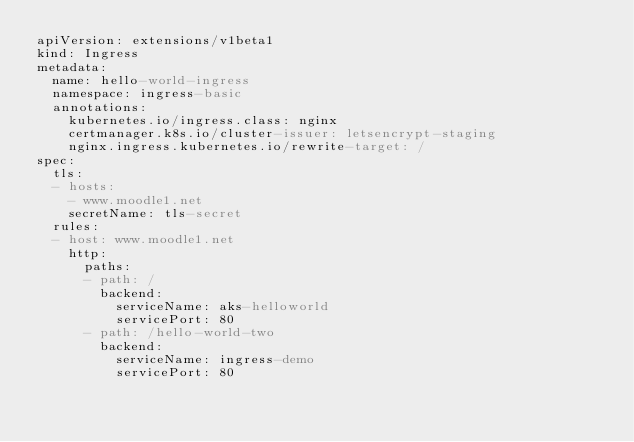<code> <loc_0><loc_0><loc_500><loc_500><_YAML_>apiVersion: extensions/v1beta1
kind: Ingress
metadata:
  name: hello-world-ingress
  namespace: ingress-basic
  annotations:
    kubernetes.io/ingress.class: nginx
    certmanager.k8s.io/cluster-issuer: letsencrypt-staging
    nginx.ingress.kubernetes.io/rewrite-target: /
spec:
  tls:
  - hosts:
    - www.moodle1.net
    secretName: tls-secret
  rules:
  - host: www.moodle1.net
    http:
      paths:
      - path: /
        backend:
          serviceName: aks-helloworld
          servicePort: 80
      - path: /hello-world-two
        backend:
          serviceName: ingress-demo
          servicePort: 80
</code> 